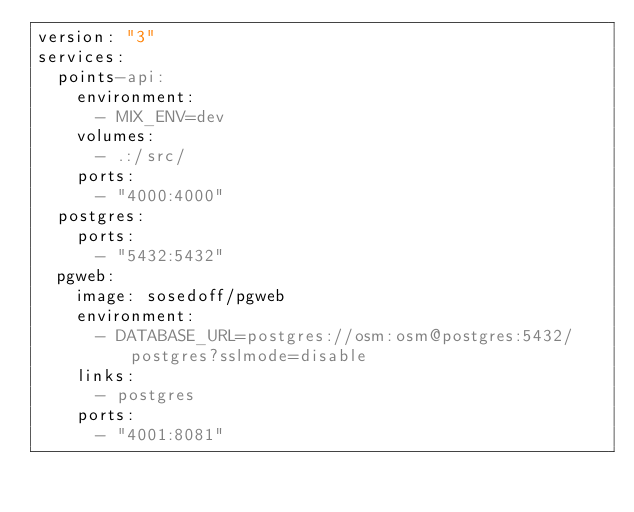<code> <loc_0><loc_0><loc_500><loc_500><_YAML_>version: "3"
services:
  points-api:
    environment:
      - MIX_ENV=dev
    volumes:
      - .:/src/
    ports:
      - "4000:4000"
  postgres:
    ports:
      - "5432:5432"
  pgweb:
    image: sosedoff/pgweb
    environment:
      - DATABASE_URL=postgres://osm:osm@postgres:5432/postgres?sslmode=disable
    links:
      - postgres
    ports:
      - "4001:8081"
</code> 